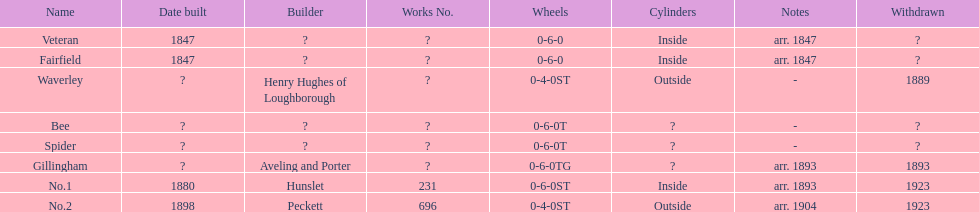After "spider," what name can be found? Gillingham. 